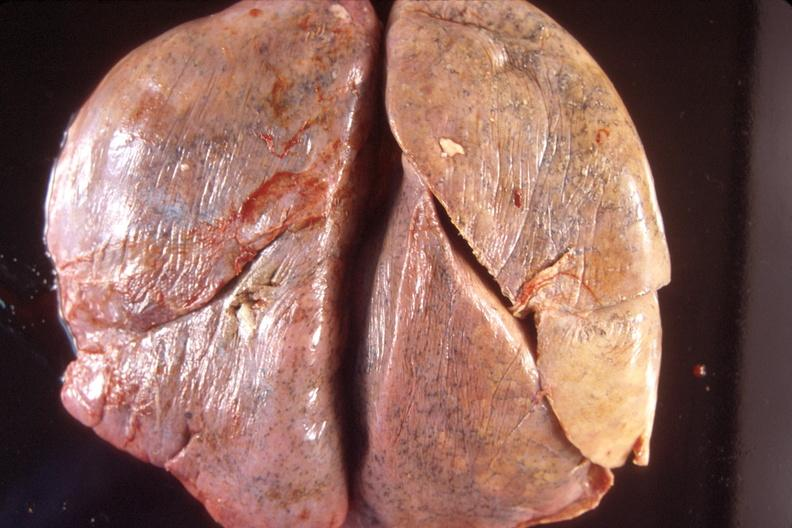does metastatic carcinoma breast show normal lung?
Answer the question using a single word or phrase. No 